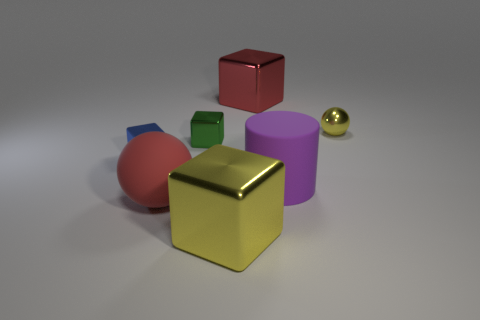Add 3 big purple matte cubes. How many objects exist? 10 Subtract all balls. How many objects are left? 5 Add 1 big cylinders. How many big cylinders are left? 2 Add 7 small metallic objects. How many small metallic objects exist? 10 Subtract 1 red spheres. How many objects are left? 6 Subtract all large red spheres. Subtract all small blue metallic cubes. How many objects are left? 5 